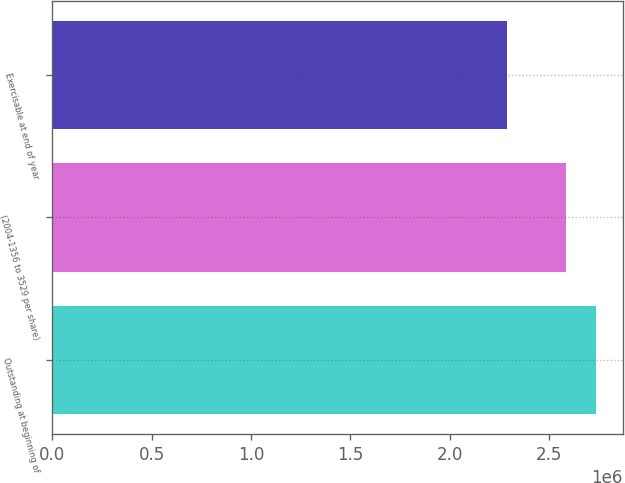<chart> <loc_0><loc_0><loc_500><loc_500><bar_chart><fcel>Outstanding at beginning of<fcel>(2004-1356 to 3529 per share)<fcel>Exercisable at end of year<nl><fcel>2.7336e+06<fcel>2.585e+06<fcel>2.2886e+06<nl></chart> 